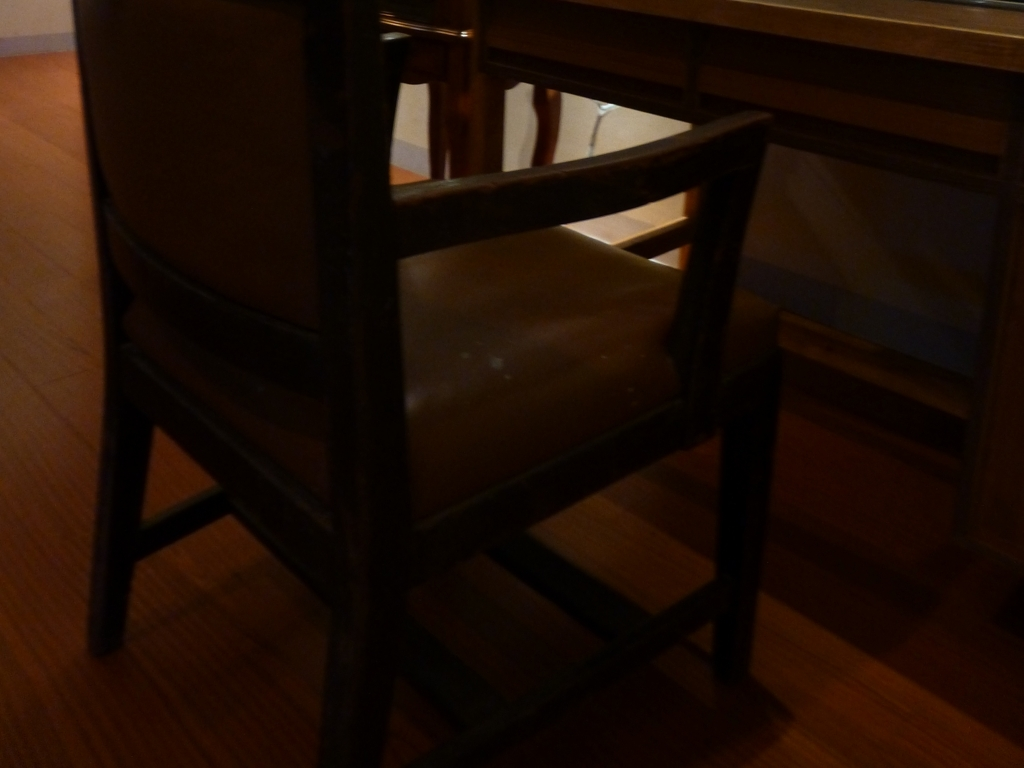What emotions does this image evoke, given the lighting and composition? The image conveys a moody and contemplative atmosphere, possibly evoking a sense of solitude or introspection. The darkness and shadowing can create a sense of mystery or foreboding. Could the image symbolize something, or could there be a story behind it? Certainly, the image of an empty chair in dim lighting can be symbolic of absence or waiting. It may suggest a narrative where someone has recently left the space or is expected to return, leaving the viewer to ponder about the context of the chair's vacancy. 